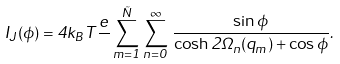<formula> <loc_0><loc_0><loc_500><loc_500>I _ { J } ( \phi ) = 4 k _ { B } T \frac { e } { } \sum _ { m = 1 } ^ { \tilde { N } } \sum _ { n = 0 } ^ { \infty } \, \frac { \sin \phi } { \cosh 2 \Omega _ { n } ( q _ { m } ) + \cos \phi } .</formula> 